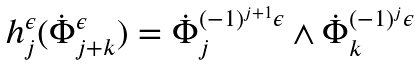Convert formula to latex. <formula><loc_0><loc_0><loc_500><loc_500>\text {\em $h_{j}^{\epsilon}(\dot{\Phi}_{j+k}^{\epsilon}) = \dot{\Phi}_{j}^{(-1)^{j+1}\epsilon} \wedge \dot{\Phi}_{k}^{(-1)^{j}\epsilon}$}</formula> 